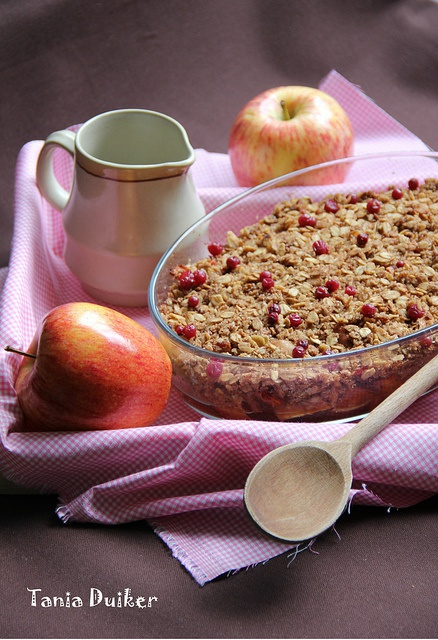Describe the objects in this image and their specific colors. I can see dining table in gray, maroon, black, brown, and lavender tones, bowl in black, maroon, tan, and brown tones, cup in black, brown, gray, darkgray, and lightgray tones, apple in black, maroon, brown, and red tones, and spoon in black, darkgray, tan, and gray tones in this image. 